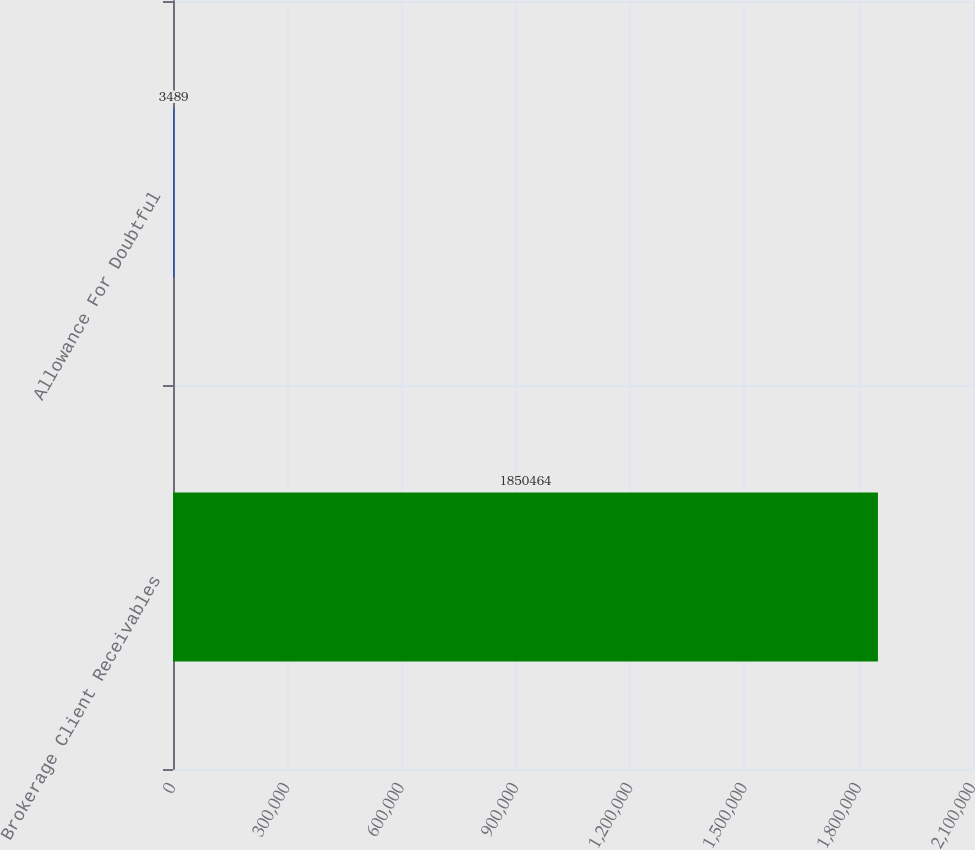Convert chart to OTSL. <chart><loc_0><loc_0><loc_500><loc_500><bar_chart><fcel>Brokerage Client Receivables<fcel>Allowance For Doubtful<nl><fcel>1.85046e+06<fcel>3489<nl></chart> 